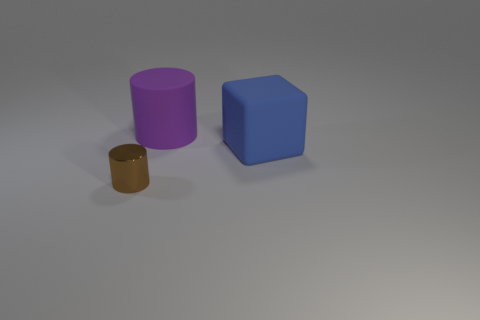Add 1 large gray balls. How many objects exist? 4 Subtract all cylinders. How many objects are left? 1 Subtract 1 blocks. How many blocks are left? 0 Subtract all yellow cylinders. How many purple cubes are left? 0 Subtract all small brown shiny objects. Subtract all purple rubber objects. How many objects are left? 1 Add 3 large purple objects. How many large purple objects are left? 4 Add 3 large things. How many large things exist? 5 Subtract all brown cylinders. How many cylinders are left? 1 Subtract 0 red spheres. How many objects are left? 3 Subtract all cyan blocks. Subtract all yellow cylinders. How many blocks are left? 1 